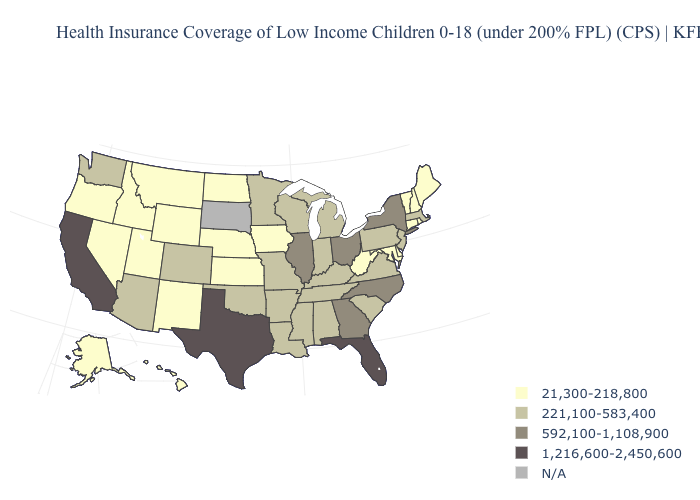Among the states that border Virginia , which have the lowest value?
Be succinct. Maryland, West Virginia. What is the value of California?
Answer briefly. 1,216,600-2,450,600. Does Arkansas have the lowest value in the USA?
Quick response, please. No. What is the lowest value in states that border Pennsylvania?
Short answer required. 21,300-218,800. What is the highest value in the South ?
Concise answer only. 1,216,600-2,450,600. Does the first symbol in the legend represent the smallest category?
Write a very short answer. Yes. Among the states that border Maryland , which have the lowest value?
Quick response, please. Delaware, West Virginia. Name the states that have a value in the range 221,100-583,400?
Keep it brief. Alabama, Arizona, Arkansas, Colorado, Indiana, Kentucky, Louisiana, Massachusetts, Michigan, Minnesota, Mississippi, Missouri, New Jersey, Oklahoma, Pennsylvania, South Carolina, Tennessee, Virginia, Washington, Wisconsin. What is the value of Illinois?
Give a very brief answer. 592,100-1,108,900. How many symbols are there in the legend?
Short answer required. 5. Name the states that have a value in the range 592,100-1,108,900?
Keep it brief. Georgia, Illinois, New York, North Carolina, Ohio. What is the value of West Virginia?
Answer briefly. 21,300-218,800. What is the value of California?
Give a very brief answer. 1,216,600-2,450,600. Among the states that border Maine , which have the lowest value?
Answer briefly. New Hampshire. 